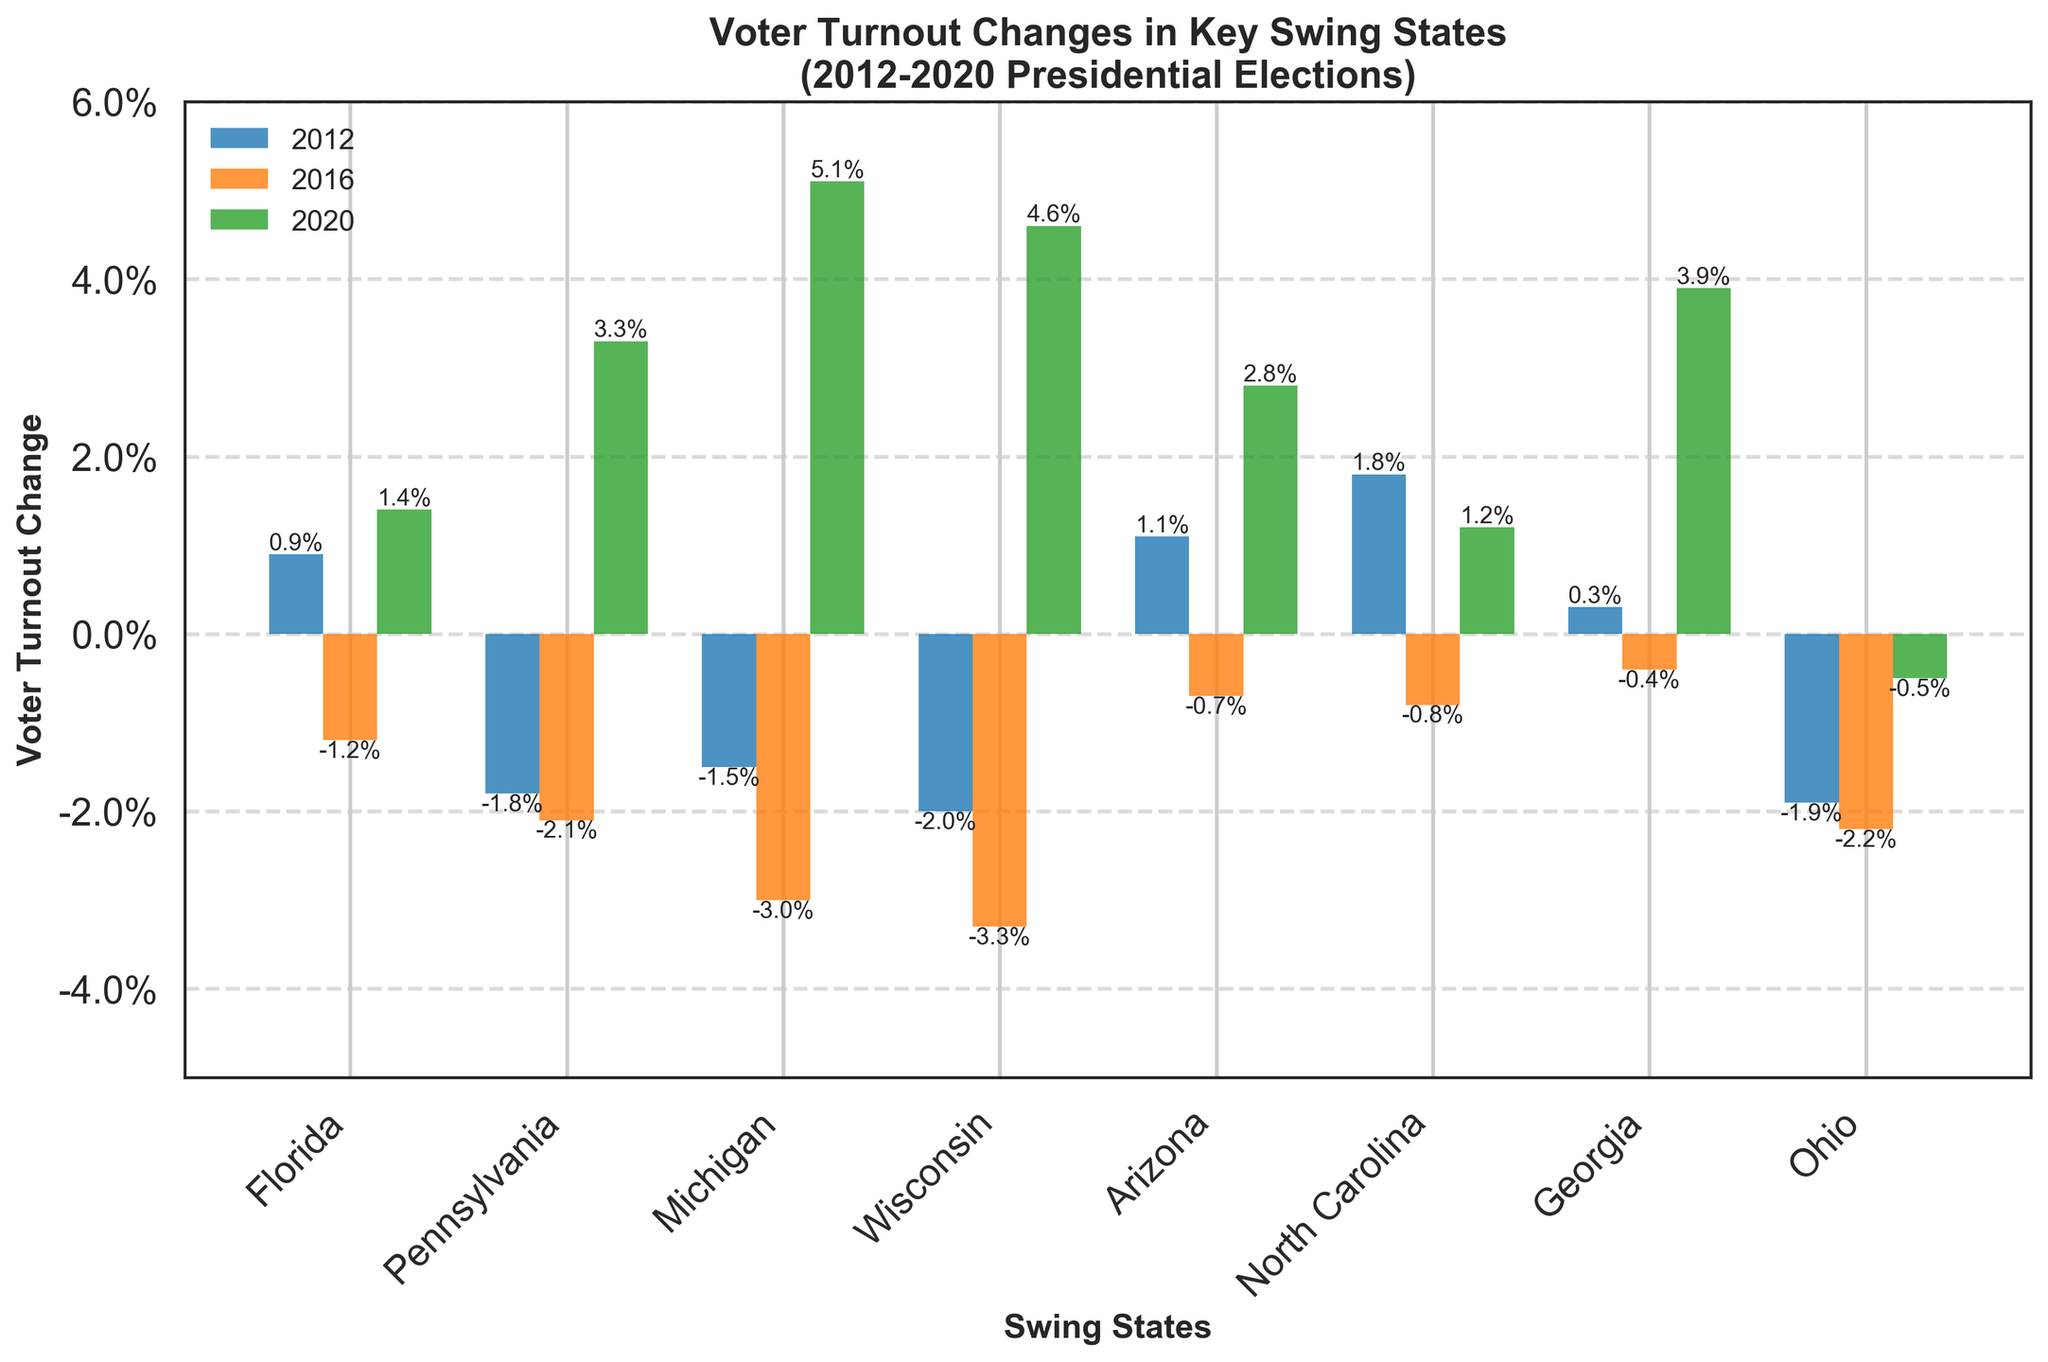What is the title of the plot? The title is displayed at the top of the plot and clearly states the subject of the figure.
Answer: Voter Turnout Changes in Key Swing States (2012-2020 Presidential Elections) How many swing states are represented in the chart? The x-axis of the chart lists the swing states included in the analysis. There are a total of eight states indicated by the x-axis labels.
Answer: Eight Which swing state had the highest increase in voter turnout in 2020? To find this, look at the green bars for each state representing the 2020 changes, and identify the highest one.
Answer: Michigan Did voter turnout in Ohio increase or decrease each election year? Examine the bars for Ohio. In 2012, 2016, and 2020, the blue, orange, and green bars show negative changes.
Answer: Decrease What was the voter turnout change in Wisconsin in 2016 compared to Florida in 2020? Look at Wisconsin's orange bar for 2016 and Florida's green bar for 2020. Wisconsin had a -3.3% while Florida had +1.4%.
Answer: Wisconsin: -3.3%, Florida: +1.4% Which election year shows the most significant increase for Pennsylvania? Check the bars for Pennsylvania across all years and identify the largest positive change, which occurs in the green bar (2020).
Answer: 2020 Compare voter turnout changes between Michigan and Wisconsin in 2020. Which state had higher voter turnout increase and by how much? Look at the green bars for Michigan and Wisconsin representing 2020 changes. Michigan had +5.1% and Wisconsin had +4.6%. The difference is 0.5%.
Answer: Michigan by 0.5% What was the trend of voter turnout changes in Arizona from 2012 to 2020? Review Arizona's bars: the blue bar shows +1.1% in 2012, the orange bar shows -0.7% in 2016, and the green bar shows +2.8% in 2020.
Answer: Increased, Decreased, Increased Which state had a positive change in voter turnout in all three election years? By examining the bars for each state across all three years, only North Carolina shows positive changes in every year.
Answer: None What's the difference in voter turnout change between Georgia and North Carolina in 2020? Check the green bars for both states in 2020. Georgia had +3.9% while North Carolina had +1.2%. The difference is 2.7%.
Answer: 2.7% 